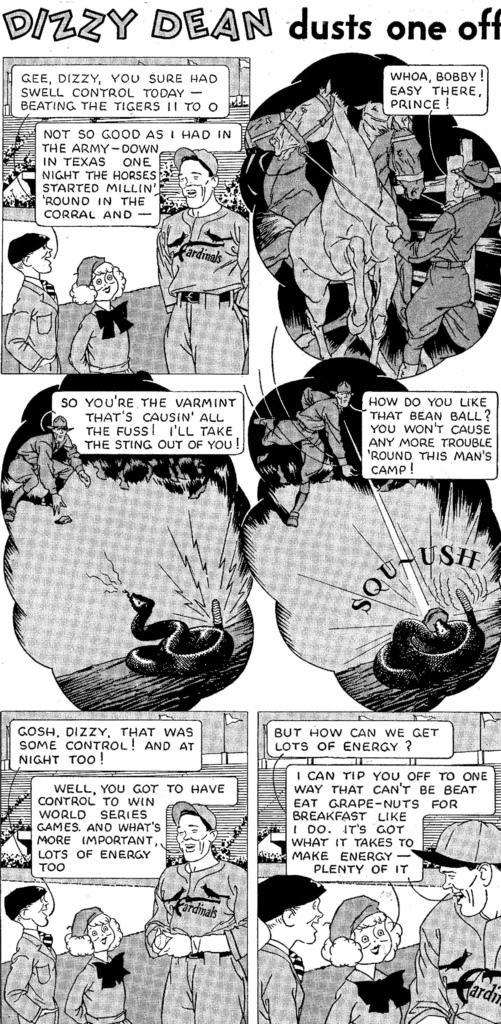Can you describe this image briefly? In this image I can see a group of people, horses, text, snakes and plants. This image looks like a paper cutting of a book. 